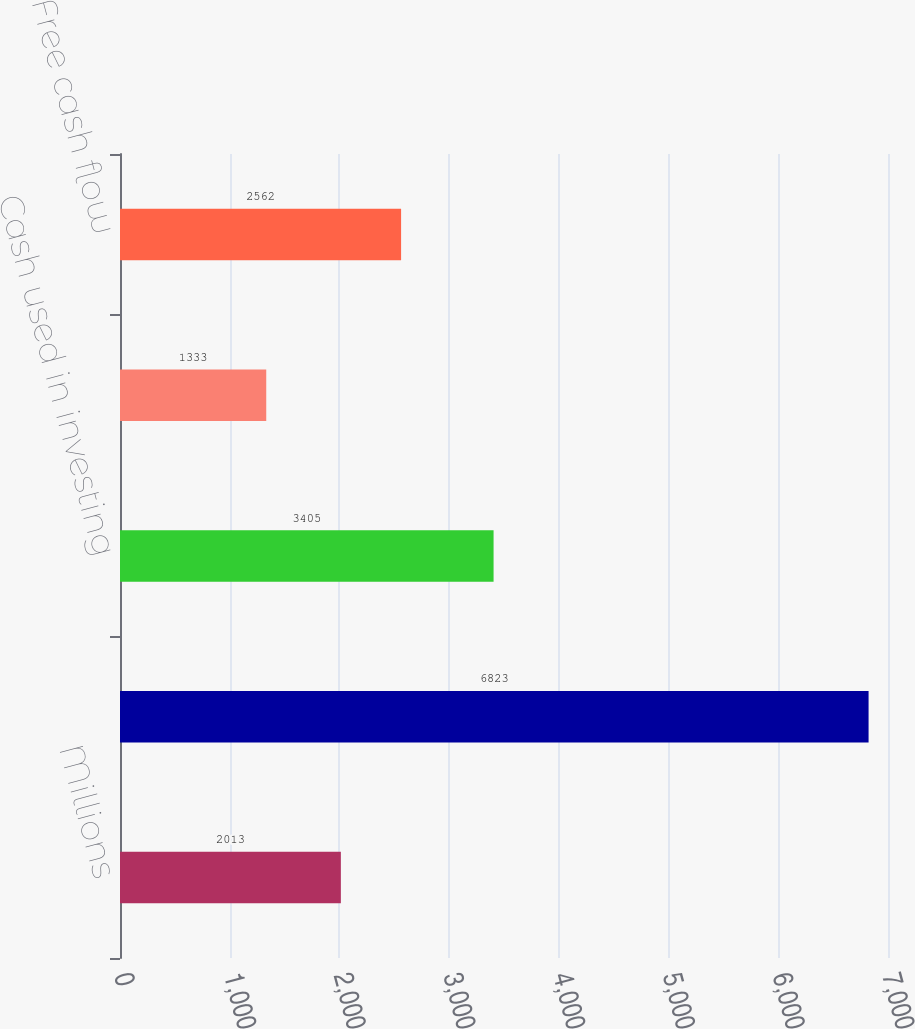Convert chart to OTSL. <chart><loc_0><loc_0><loc_500><loc_500><bar_chart><fcel>Millions<fcel>Cash provided by operating<fcel>Cash used in investing<fcel>Dividends paid<fcel>Free cash flow<nl><fcel>2013<fcel>6823<fcel>3405<fcel>1333<fcel>2562<nl></chart> 